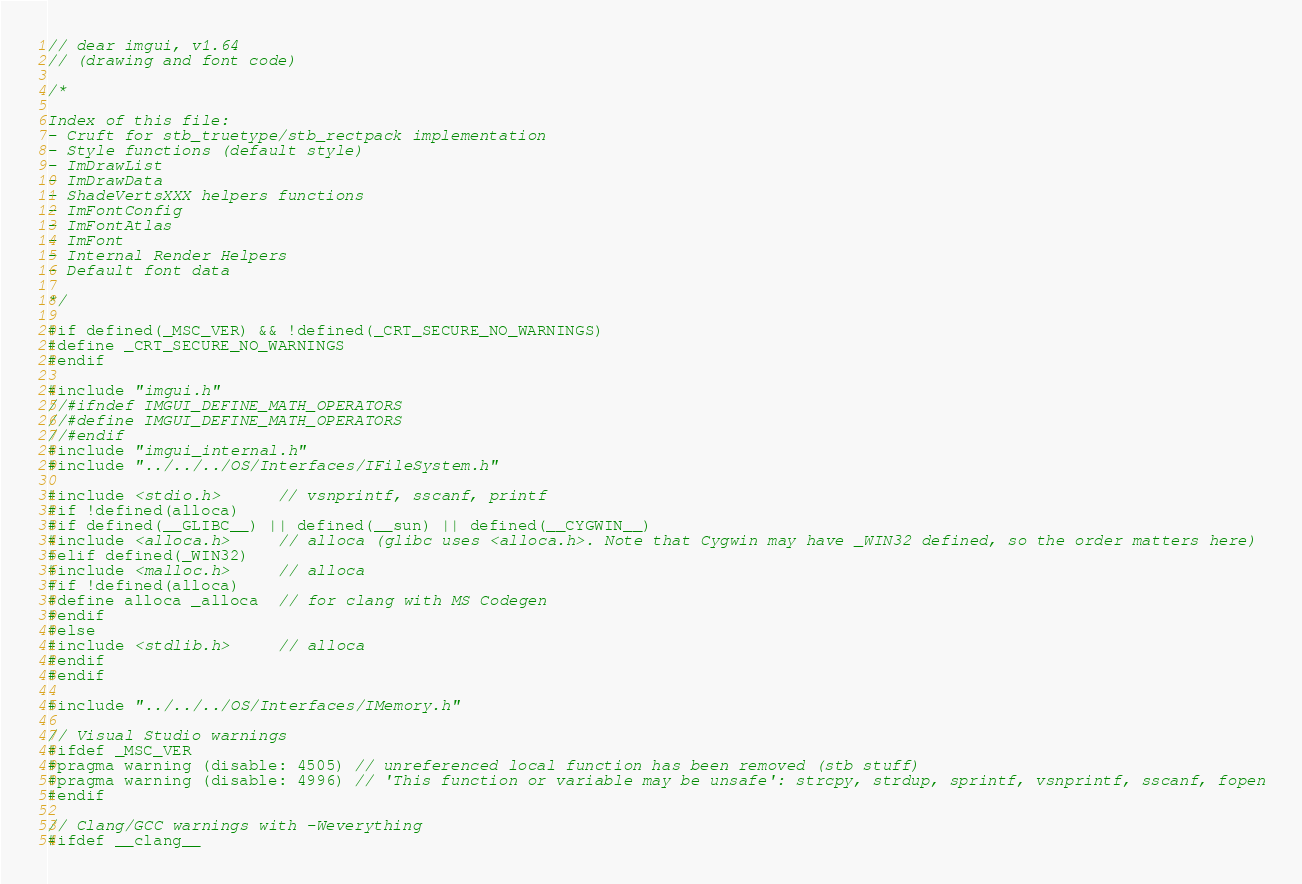<code> <loc_0><loc_0><loc_500><loc_500><_C++_>// dear imgui, v1.64
// (drawing and font code)

/*

Index of this file:
- Cruft for stb_truetype/stb_rectpack implementation
- Style functions (default style)
- ImDrawList
- ImDrawData
- ShadeVertsXXX helpers functions
- ImFontConfig
- ImFontAtlas
- ImFont
- Internal Render Helpers
- Default font data

*/

#if defined(_MSC_VER) && !defined(_CRT_SECURE_NO_WARNINGS)
#define _CRT_SECURE_NO_WARNINGS
#endif

#include "imgui.h"
//#ifndef IMGUI_DEFINE_MATH_OPERATORS
//#define IMGUI_DEFINE_MATH_OPERATORS
//#endif
#include "imgui_internal.h"
#include "../../../OS/Interfaces/IFileSystem.h"

#include <stdio.h>      // vsnprintf, sscanf, printf
#if !defined(alloca)
#if defined(__GLIBC__) || defined(__sun) || defined(__CYGWIN__)
#include <alloca.h>     // alloca (glibc uses <alloca.h>. Note that Cygwin may have _WIN32 defined, so the order matters here)
#elif defined(_WIN32)
#include <malloc.h>     // alloca
#if !defined(alloca)
#define alloca _alloca  // for clang with MS Codegen
#endif
#else
#include <stdlib.h>     // alloca
#endif
#endif

#include "../../../OS/Interfaces/IMemory.h"

// Visual Studio warnings
#ifdef _MSC_VER
#pragma warning (disable: 4505) // unreferenced local function has been removed (stb stuff)
#pragma warning (disable: 4996) // 'This function or variable may be unsafe': strcpy, strdup, sprintf, vsnprintf, sscanf, fopen
#endif

// Clang/GCC warnings with -Weverything
#ifdef __clang__</code> 